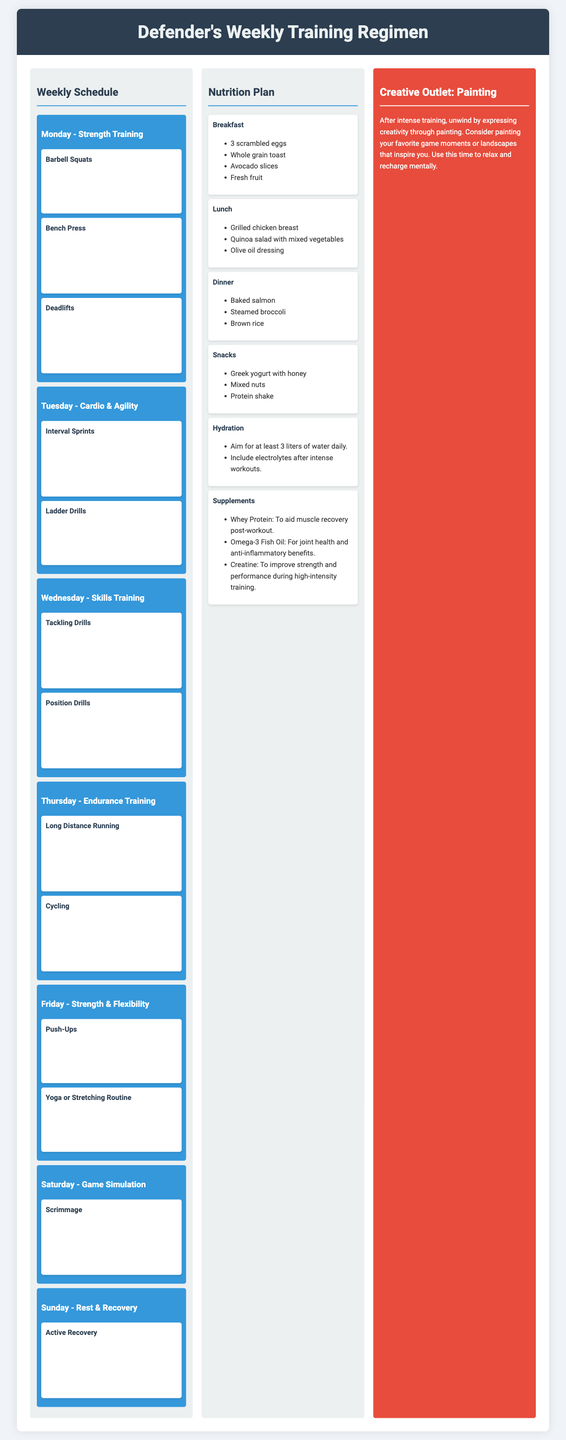What is the main focus of Monday's training? Monday's training focuses on strength training, which includes exercises such as Barbell Squats, Bench Press, and Deadlifts.
Answer: Strength Training How long is the interval sprints session? The interval sprints session on Tuesday has a duration of 30 minutes as specified in the document.
Answer: 30 minutes What type of meal is scheduled for lunch? The lunch meal consists of grilled chicken breast, quinoa salad with mixed vegetables, and olive oil dressing as described.
Answer: Grilled chicken breast Which exercise is performed on Saturday? On Saturday, the scrimmage exercise is performed, simulating game conditions for 90 minutes.
Answer: Scrimmage What is the total number of sets for Push-Ups on Friday? The total number of sets for Push-Ups on Friday is 3 sets, as indicated in the exercise description.
Answer: 3 sets How many meals are included in the nutrition plan? The nutrition plan includes six meals, detailing breakfast, lunch, dinner, snacks, hydration, and supplements.
Answer: Six meals What type of exercise is included on Thursday? Thursday's training includes endurance training activities such as long-distance running and cycling.
Answer: Endurance Training What is a recommended hydration goal? The document recommends aiming for at least 3 liters of water daily for hydration purposes.
Answer: 3 liters What creative outlet is suggested for post-training? The suggested creative outlet for unwinding after training is painting, which allows for relaxation and expression.
Answer: Painting 